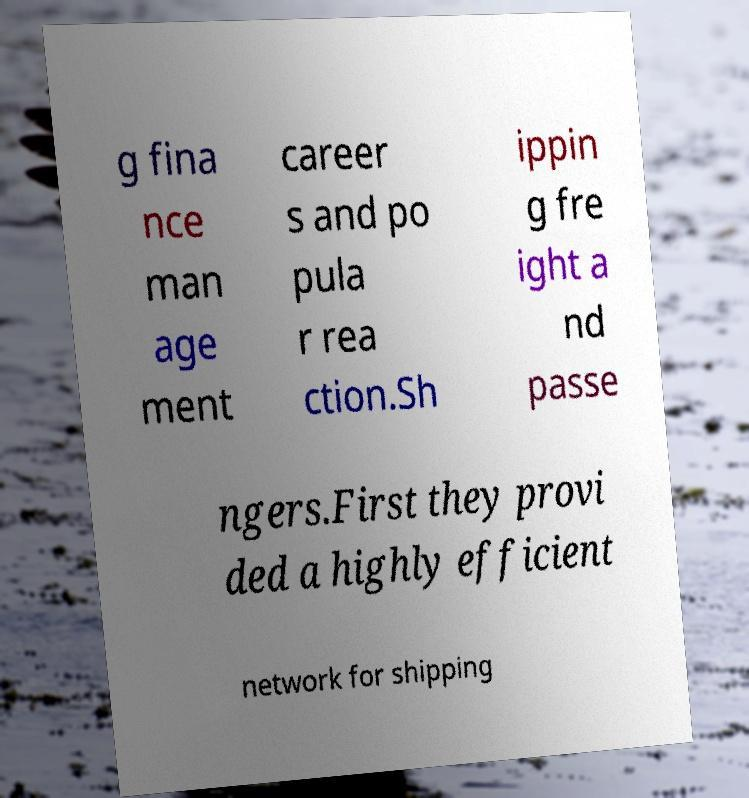Could you extract and type out the text from this image? g fina nce man age ment career s and po pula r rea ction.Sh ippin g fre ight a nd passe ngers.First they provi ded a highly efficient network for shipping 